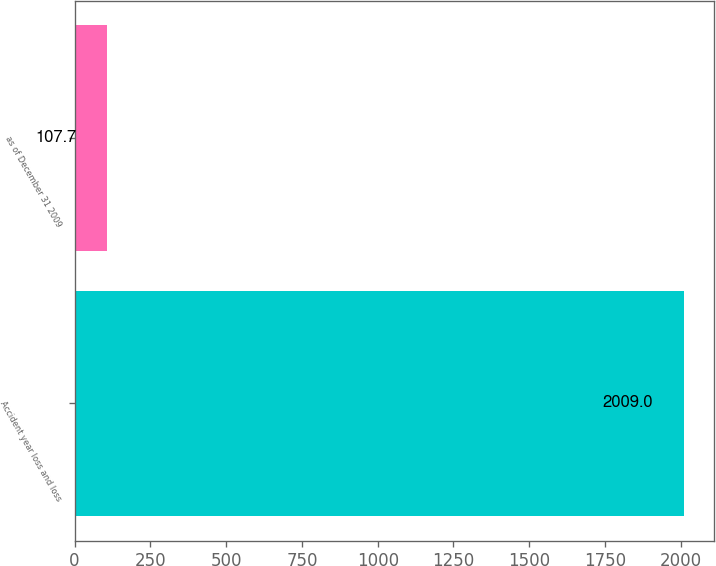Convert chart to OTSL. <chart><loc_0><loc_0><loc_500><loc_500><bar_chart><fcel>Accident year loss and loss<fcel>as of December 31 2009<nl><fcel>2009<fcel>107.7<nl></chart> 